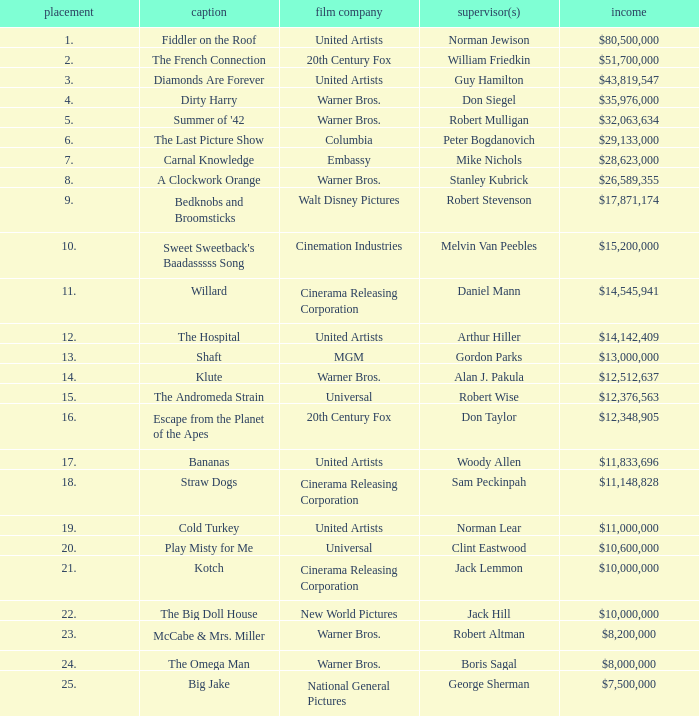Which title positioned below 19 has a gross revenue of $11,833,696? Bananas. 